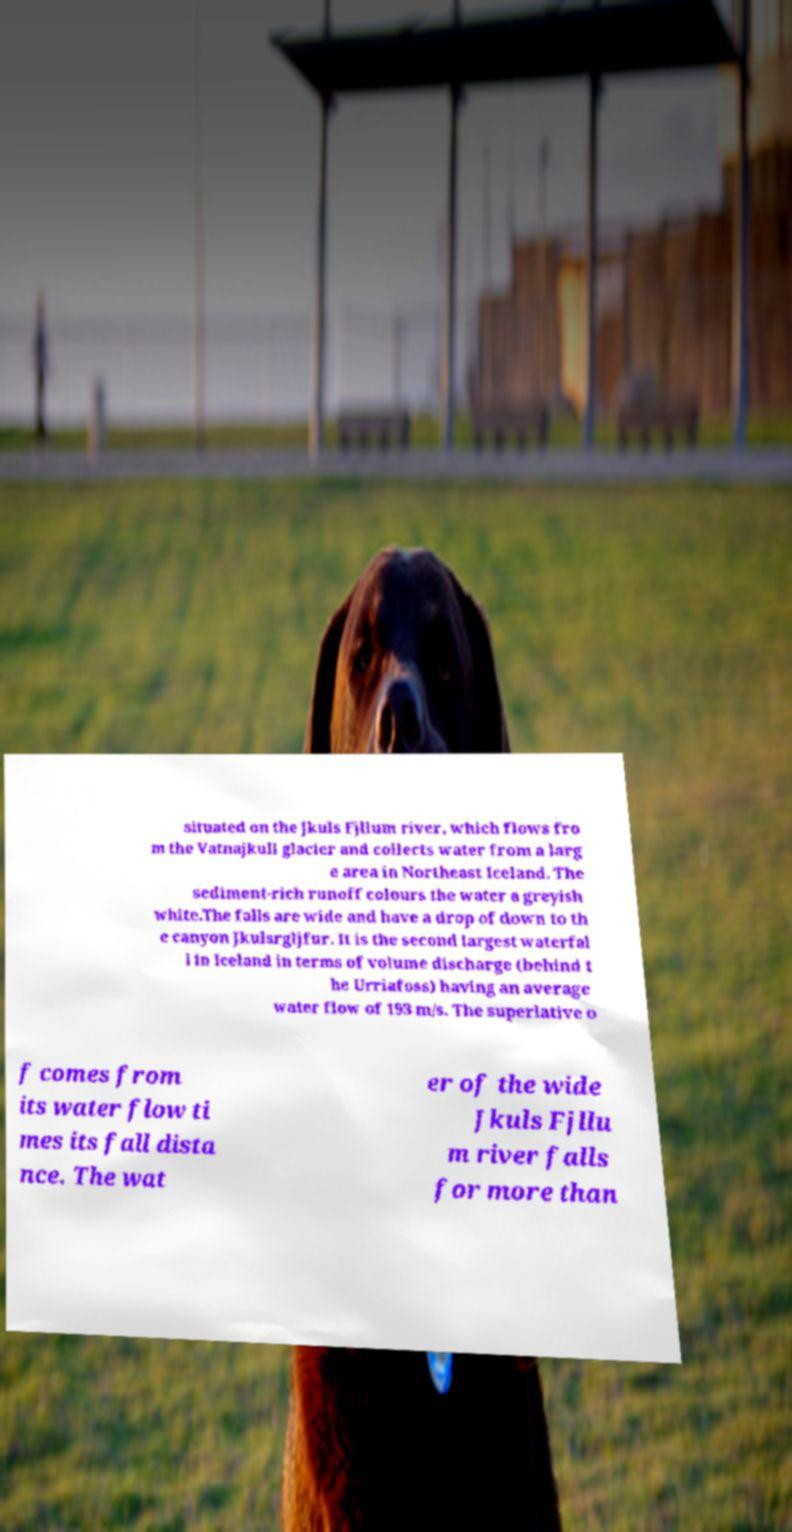For documentation purposes, I need the text within this image transcribed. Could you provide that? situated on the Jkuls Fjllum river, which flows fro m the Vatnajkull glacier and collects water from a larg e area in Northeast Iceland. The sediment-rich runoff colours the water a greyish white.The falls are wide and have a drop of down to th e canyon Jkulsrgljfur. It is the second largest waterfal l in Iceland in terms of volume discharge (behind t he Urriafoss) having an average water flow of 193 m/s. The superlative o f comes from its water flow ti mes its fall dista nce. The wat er of the wide Jkuls Fjllu m river falls for more than 